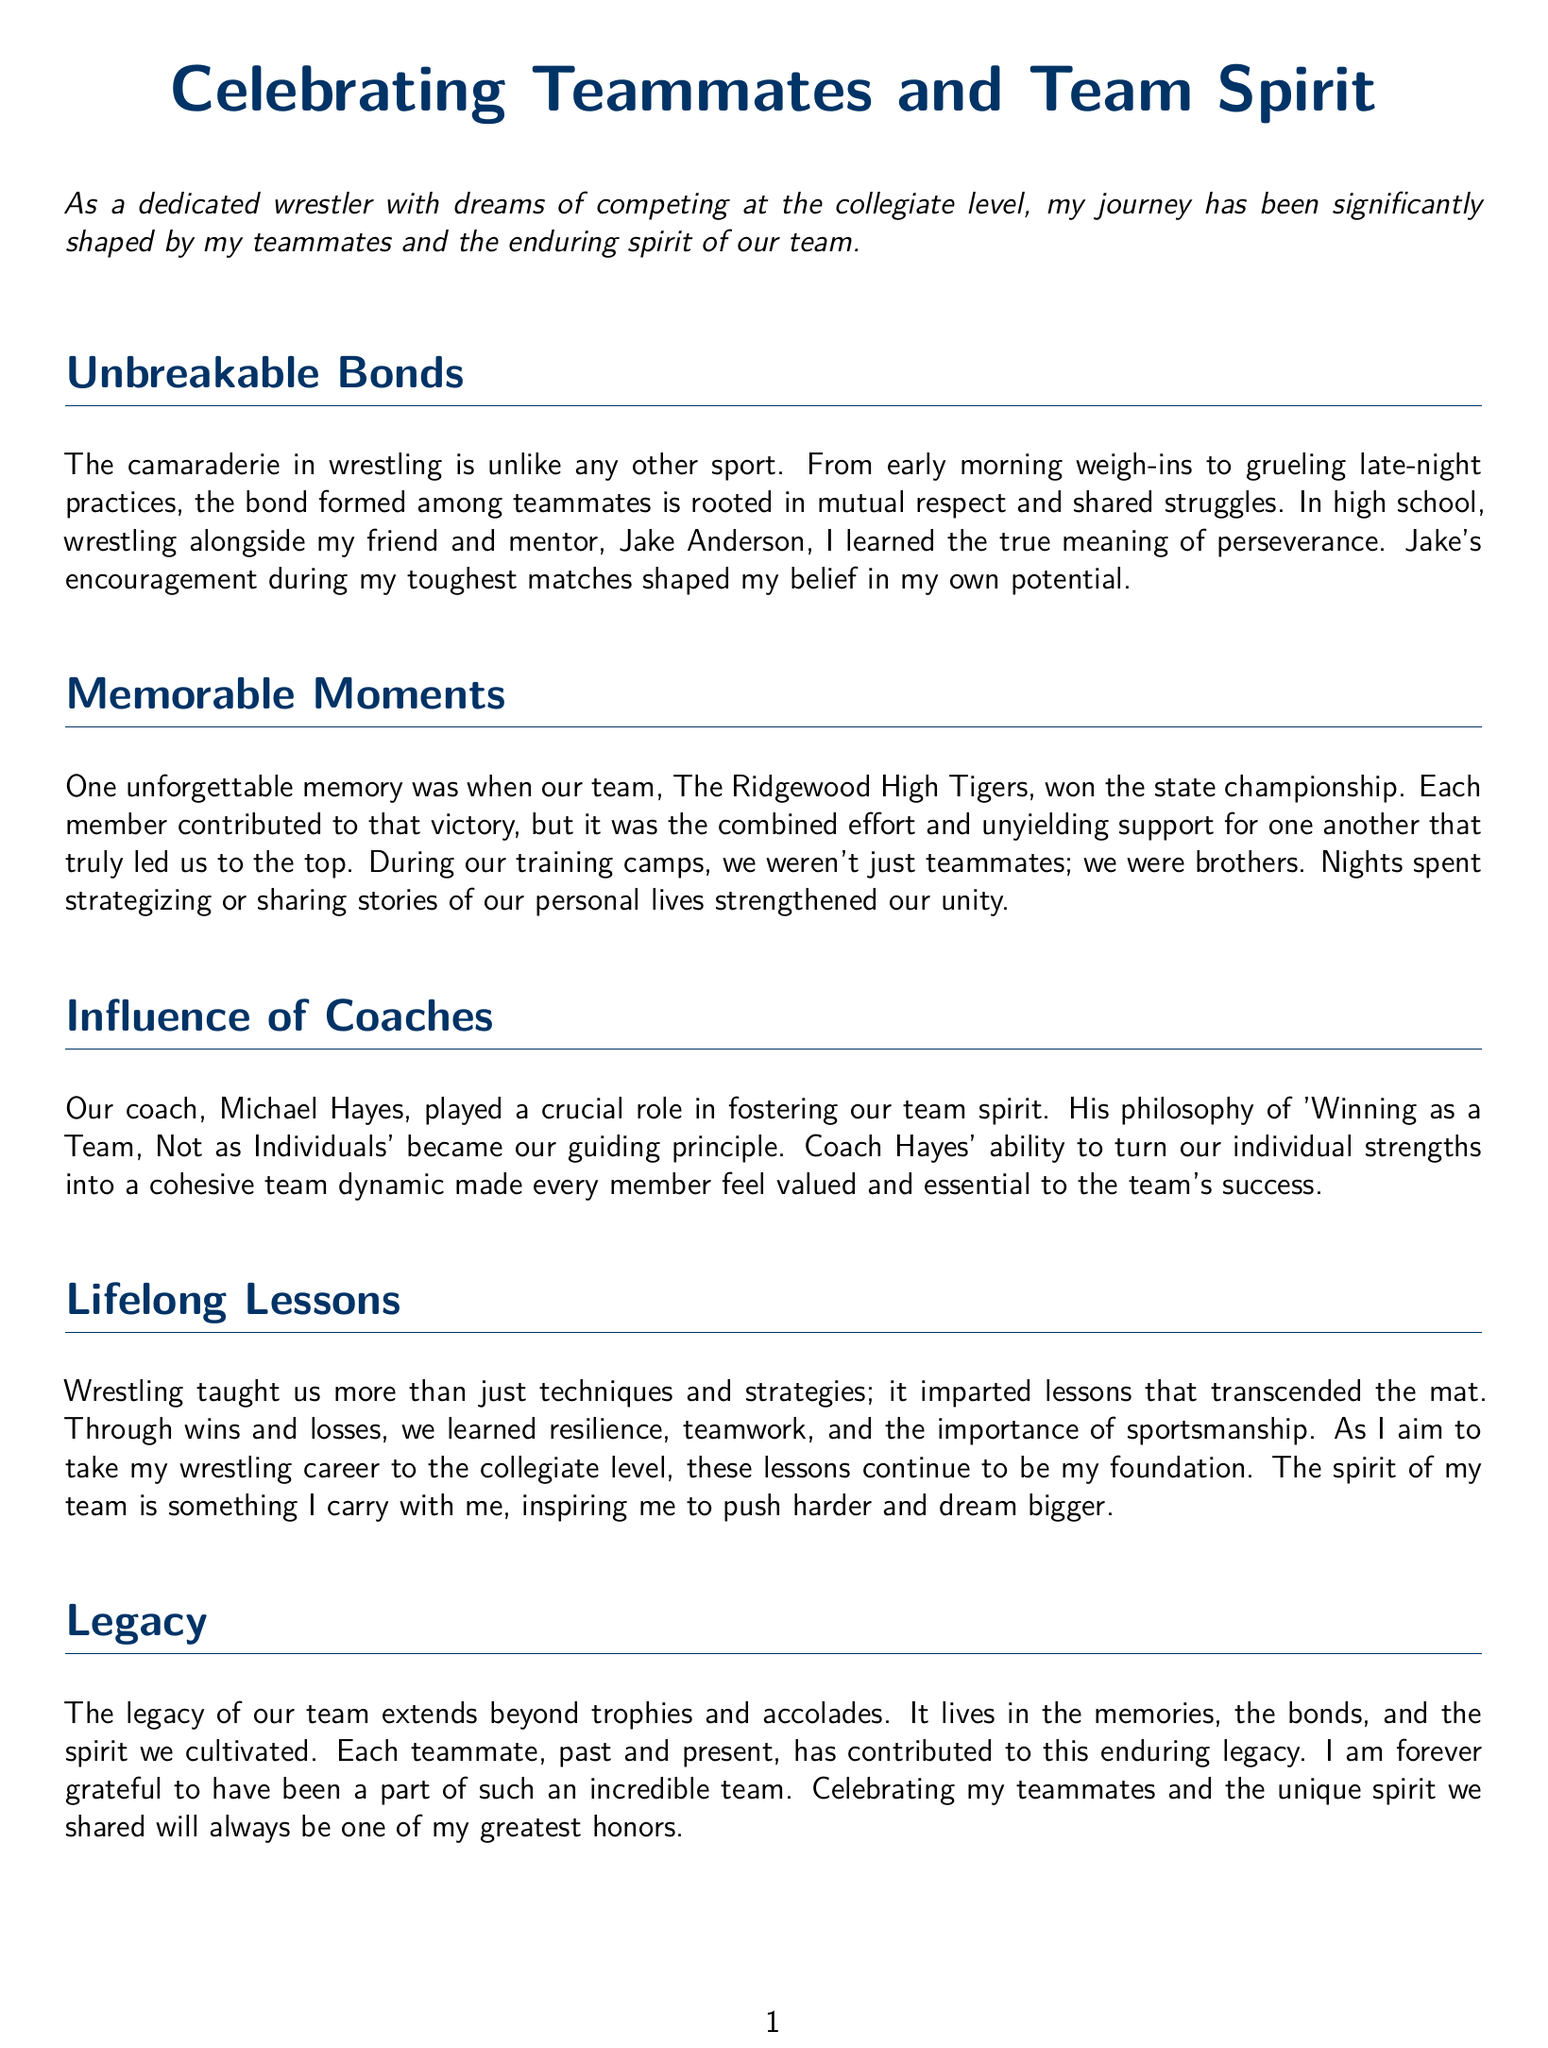What was the name of the team? The document refers to the team as "The Ridgewood High Tigers."
Answer: The Ridgewood High Tigers Who was the mentor mentioned in the eulogy? The text specifies Jake Anderson as a friend and mentor.
Answer: Jake Anderson What was the state achievement mentioned? The document states the team won the state championship.
Answer: state championship What lesson is emphasized through wrestling? The eulogy discusses resilience, teamwork, and sportsmanship as lifelong lessons.
Answer: resilience, teamwork, sportsmanship Who was the coach that influenced the team? The document cites Michael Hayes as the influential coach.
Answer: Michael Hayes 